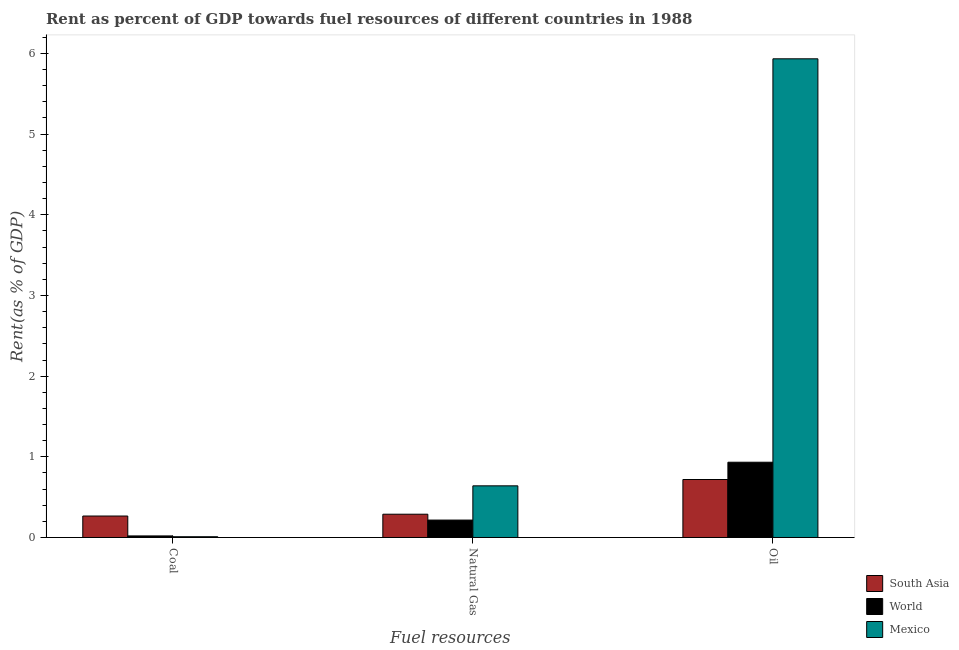How many different coloured bars are there?
Provide a succinct answer. 3. Are the number of bars per tick equal to the number of legend labels?
Your answer should be compact. Yes. How many bars are there on the 1st tick from the left?
Keep it short and to the point. 3. How many bars are there on the 1st tick from the right?
Ensure brevity in your answer.  3. What is the label of the 2nd group of bars from the left?
Give a very brief answer. Natural Gas. What is the rent towards oil in World?
Ensure brevity in your answer.  0.93. Across all countries, what is the maximum rent towards coal?
Make the answer very short. 0.27. Across all countries, what is the minimum rent towards natural gas?
Offer a terse response. 0.22. What is the total rent towards coal in the graph?
Make the answer very short. 0.29. What is the difference between the rent towards coal in Mexico and that in World?
Ensure brevity in your answer.  -0.01. What is the difference between the rent towards oil in South Asia and the rent towards coal in Mexico?
Your answer should be compact. 0.71. What is the average rent towards natural gas per country?
Offer a terse response. 0.38. What is the difference between the rent towards coal and rent towards oil in South Asia?
Offer a very short reply. -0.45. In how many countries, is the rent towards natural gas greater than 1.4 %?
Provide a succinct answer. 0. What is the ratio of the rent towards natural gas in Mexico to that in South Asia?
Offer a very short reply. 2.22. What is the difference between the highest and the second highest rent towards natural gas?
Provide a short and direct response. 0.35. What is the difference between the highest and the lowest rent towards coal?
Keep it short and to the point. 0.26. Is the sum of the rent towards natural gas in South Asia and Mexico greater than the maximum rent towards coal across all countries?
Your response must be concise. Yes. What does the 2nd bar from the left in Coal represents?
Give a very brief answer. World. Is it the case that in every country, the sum of the rent towards coal and rent towards natural gas is greater than the rent towards oil?
Ensure brevity in your answer.  No. How many bars are there?
Provide a succinct answer. 9. Are all the bars in the graph horizontal?
Give a very brief answer. No. Are the values on the major ticks of Y-axis written in scientific E-notation?
Provide a succinct answer. No. Does the graph contain grids?
Offer a very short reply. No. How are the legend labels stacked?
Give a very brief answer. Vertical. What is the title of the graph?
Keep it short and to the point. Rent as percent of GDP towards fuel resources of different countries in 1988. What is the label or title of the X-axis?
Provide a succinct answer. Fuel resources. What is the label or title of the Y-axis?
Provide a succinct answer. Rent(as % of GDP). What is the Rent(as % of GDP) in South Asia in Coal?
Ensure brevity in your answer.  0.27. What is the Rent(as % of GDP) in World in Coal?
Provide a short and direct response. 0.02. What is the Rent(as % of GDP) of Mexico in Coal?
Your answer should be very brief. 0.01. What is the Rent(as % of GDP) of South Asia in Natural Gas?
Offer a very short reply. 0.29. What is the Rent(as % of GDP) of World in Natural Gas?
Offer a terse response. 0.22. What is the Rent(as % of GDP) in Mexico in Natural Gas?
Keep it short and to the point. 0.64. What is the Rent(as % of GDP) of South Asia in Oil?
Your response must be concise. 0.72. What is the Rent(as % of GDP) in World in Oil?
Make the answer very short. 0.93. What is the Rent(as % of GDP) in Mexico in Oil?
Provide a short and direct response. 5.93. Across all Fuel resources, what is the maximum Rent(as % of GDP) of South Asia?
Make the answer very short. 0.72. Across all Fuel resources, what is the maximum Rent(as % of GDP) of World?
Offer a very short reply. 0.93. Across all Fuel resources, what is the maximum Rent(as % of GDP) of Mexico?
Offer a terse response. 5.93. Across all Fuel resources, what is the minimum Rent(as % of GDP) of South Asia?
Provide a succinct answer. 0.27. Across all Fuel resources, what is the minimum Rent(as % of GDP) in World?
Give a very brief answer. 0.02. Across all Fuel resources, what is the minimum Rent(as % of GDP) in Mexico?
Keep it short and to the point. 0.01. What is the total Rent(as % of GDP) of South Asia in the graph?
Offer a terse response. 1.27. What is the total Rent(as % of GDP) of World in the graph?
Ensure brevity in your answer.  1.17. What is the total Rent(as % of GDP) in Mexico in the graph?
Offer a terse response. 6.58. What is the difference between the Rent(as % of GDP) in South Asia in Coal and that in Natural Gas?
Offer a very short reply. -0.02. What is the difference between the Rent(as % of GDP) of World in Coal and that in Natural Gas?
Offer a terse response. -0.2. What is the difference between the Rent(as % of GDP) in Mexico in Coal and that in Natural Gas?
Your answer should be very brief. -0.63. What is the difference between the Rent(as % of GDP) in South Asia in Coal and that in Oil?
Offer a very short reply. -0.45. What is the difference between the Rent(as % of GDP) of World in Coal and that in Oil?
Make the answer very short. -0.91. What is the difference between the Rent(as % of GDP) of Mexico in Coal and that in Oil?
Offer a very short reply. -5.92. What is the difference between the Rent(as % of GDP) in South Asia in Natural Gas and that in Oil?
Provide a short and direct response. -0.43. What is the difference between the Rent(as % of GDP) of World in Natural Gas and that in Oil?
Keep it short and to the point. -0.72. What is the difference between the Rent(as % of GDP) in Mexico in Natural Gas and that in Oil?
Provide a succinct answer. -5.29. What is the difference between the Rent(as % of GDP) in South Asia in Coal and the Rent(as % of GDP) in World in Natural Gas?
Provide a short and direct response. 0.05. What is the difference between the Rent(as % of GDP) in South Asia in Coal and the Rent(as % of GDP) in Mexico in Natural Gas?
Keep it short and to the point. -0.37. What is the difference between the Rent(as % of GDP) of World in Coal and the Rent(as % of GDP) of Mexico in Natural Gas?
Your response must be concise. -0.62. What is the difference between the Rent(as % of GDP) in South Asia in Coal and the Rent(as % of GDP) in World in Oil?
Your response must be concise. -0.67. What is the difference between the Rent(as % of GDP) of South Asia in Coal and the Rent(as % of GDP) of Mexico in Oil?
Ensure brevity in your answer.  -5.67. What is the difference between the Rent(as % of GDP) of World in Coal and the Rent(as % of GDP) of Mexico in Oil?
Provide a succinct answer. -5.91. What is the difference between the Rent(as % of GDP) of South Asia in Natural Gas and the Rent(as % of GDP) of World in Oil?
Provide a succinct answer. -0.64. What is the difference between the Rent(as % of GDP) of South Asia in Natural Gas and the Rent(as % of GDP) of Mexico in Oil?
Your response must be concise. -5.64. What is the difference between the Rent(as % of GDP) of World in Natural Gas and the Rent(as % of GDP) of Mexico in Oil?
Offer a terse response. -5.72. What is the average Rent(as % of GDP) of South Asia per Fuel resources?
Make the answer very short. 0.42. What is the average Rent(as % of GDP) of World per Fuel resources?
Make the answer very short. 0.39. What is the average Rent(as % of GDP) in Mexico per Fuel resources?
Keep it short and to the point. 2.19. What is the difference between the Rent(as % of GDP) of South Asia and Rent(as % of GDP) of World in Coal?
Provide a succinct answer. 0.25. What is the difference between the Rent(as % of GDP) of South Asia and Rent(as % of GDP) of Mexico in Coal?
Keep it short and to the point. 0.26. What is the difference between the Rent(as % of GDP) in South Asia and Rent(as % of GDP) in World in Natural Gas?
Your answer should be compact. 0.07. What is the difference between the Rent(as % of GDP) of South Asia and Rent(as % of GDP) of Mexico in Natural Gas?
Offer a terse response. -0.35. What is the difference between the Rent(as % of GDP) in World and Rent(as % of GDP) in Mexico in Natural Gas?
Your response must be concise. -0.42. What is the difference between the Rent(as % of GDP) in South Asia and Rent(as % of GDP) in World in Oil?
Provide a succinct answer. -0.21. What is the difference between the Rent(as % of GDP) of South Asia and Rent(as % of GDP) of Mexico in Oil?
Provide a succinct answer. -5.21. What is the difference between the Rent(as % of GDP) of World and Rent(as % of GDP) of Mexico in Oil?
Make the answer very short. -5. What is the ratio of the Rent(as % of GDP) in South Asia in Coal to that in Natural Gas?
Keep it short and to the point. 0.92. What is the ratio of the Rent(as % of GDP) of World in Coal to that in Natural Gas?
Offer a very short reply. 0.09. What is the ratio of the Rent(as % of GDP) of Mexico in Coal to that in Natural Gas?
Offer a terse response. 0.01. What is the ratio of the Rent(as % of GDP) of South Asia in Coal to that in Oil?
Your answer should be compact. 0.37. What is the ratio of the Rent(as % of GDP) of World in Coal to that in Oil?
Give a very brief answer. 0.02. What is the ratio of the Rent(as % of GDP) of Mexico in Coal to that in Oil?
Give a very brief answer. 0. What is the ratio of the Rent(as % of GDP) in South Asia in Natural Gas to that in Oil?
Ensure brevity in your answer.  0.4. What is the ratio of the Rent(as % of GDP) of World in Natural Gas to that in Oil?
Give a very brief answer. 0.23. What is the ratio of the Rent(as % of GDP) of Mexico in Natural Gas to that in Oil?
Offer a terse response. 0.11. What is the difference between the highest and the second highest Rent(as % of GDP) in South Asia?
Your answer should be very brief. 0.43. What is the difference between the highest and the second highest Rent(as % of GDP) in World?
Your answer should be compact. 0.72. What is the difference between the highest and the second highest Rent(as % of GDP) in Mexico?
Make the answer very short. 5.29. What is the difference between the highest and the lowest Rent(as % of GDP) of South Asia?
Your answer should be compact. 0.45. What is the difference between the highest and the lowest Rent(as % of GDP) in World?
Keep it short and to the point. 0.91. What is the difference between the highest and the lowest Rent(as % of GDP) in Mexico?
Ensure brevity in your answer.  5.92. 